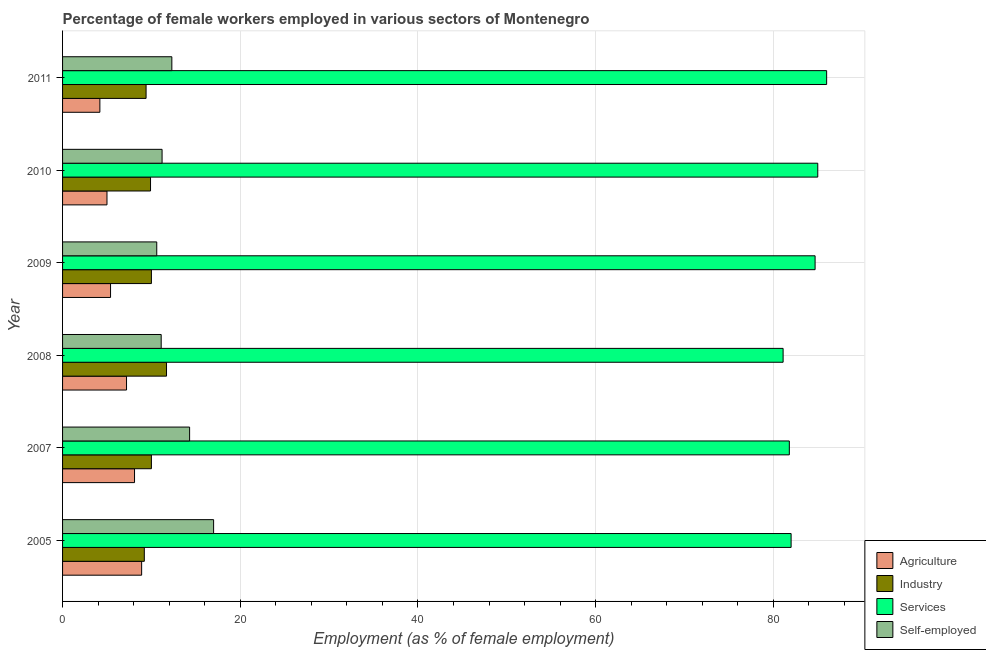How many groups of bars are there?
Make the answer very short. 6. Are the number of bars per tick equal to the number of legend labels?
Your answer should be compact. Yes. Are the number of bars on each tick of the Y-axis equal?
Provide a succinct answer. Yes. What is the label of the 6th group of bars from the top?
Ensure brevity in your answer.  2005. What is the percentage of female workers in agriculture in 2011?
Your answer should be compact. 4.2. Across all years, what is the maximum percentage of female workers in agriculture?
Provide a succinct answer. 8.9. Across all years, what is the minimum percentage of female workers in agriculture?
Your answer should be very brief. 4.2. In which year was the percentage of female workers in industry minimum?
Provide a succinct answer. 2005. What is the total percentage of female workers in industry in the graph?
Offer a terse response. 60.2. What is the difference between the percentage of female workers in services in 2009 and that in 2011?
Offer a very short reply. -1.3. What is the difference between the percentage of female workers in industry in 2005 and the percentage of female workers in agriculture in 2008?
Provide a succinct answer. 2. What is the average percentage of female workers in services per year?
Provide a short and direct response. 83.43. In the year 2007, what is the difference between the percentage of self employed female workers and percentage of female workers in agriculture?
Ensure brevity in your answer.  6.2. What is the ratio of the percentage of self employed female workers in 2007 to that in 2008?
Give a very brief answer. 1.29. Is the percentage of female workers in industry in 2009 less than that in 2010?
Offer a terse response. No. Is the difference between the percentage of female workers in agriculture in 2007 and 2008 greater than the difference between the percentage of self employed female workers in 2007 and 2008?
Keep it short and to the point. No. What is the difference between the highest and the second highest percentage of female workers in agriculture?
Offer a very short reply. 0.8. In how many years, is the percentage of female workers in industry greater than the average percentage of female workers in industry taken over all years?
Your answer should be very brief. 1. Is the sum of the percentage of female workers in industry in 2007 and 2011 greater than the maximum percentage of female workers in services across all years?
Give a very brief answer. No. Is it the case that in every year, the sum of the percentage of female workers in services and percentage of female workers in industry is greater than the sum of percentage of self employed female workers and percentage of female workers in agriculture?
Your answer should be very brief. Yes. What does the 1st bar from the top in 2007 represents?
Provide a succinct answer. Self-employed. What does the 2nd bar from the bottom in 2005 represents?
Give a very brief answer. Industry. How many bars are there?
Offer a very short reply. 24. Are all the bars in the graph horizontal?
Give a very brief answer. Yes. How many years are there in the graph?
Offer a very short reply. 6. What is the title of the graph?
Provide a short and direct response. Percentage of female workers employed in various sectors of Montenegro. Does "Manufacturing" appear as one of the legend labels in the graph?
Your response must be concise. No. What is the label or title of the X-axis?
Your response must be concise. Employment (as % of female employment). What is the Employment (as % of female employment) in Agriculture in 2005?
Keep it short and to the point. 8.9. What is the Employment (as % of female employment) of Industry in 2005?
Offer a very short reply. 9.2. What is the Employment (as % of female employment) in Self-employed in 2005?
Ensure brevity in your answer.  17. What is the Employment (as % of female employment) in Agriculture in 2007?
Your answer should be compact. 8.1. What is the Employment (as % of female employment) of Industry in 2007?
Ensure brevity in your answer.  10. What is the Employment (as % of female employment) of Services in 2007?
Give a very brief answer. 81.8. What is the Employment (as % of female employment) of Self-employed in 2007?
Ensure brevity in your answer.  14.3. What is the Employment (as % of female employment) in Agriculture in 2008?
Your answer should be compact. 7.2. What is the Employment (as % of female employment) in Industry in 2008?
Make the answer very short. 11.7. What is the Employment (as % of female employment) of Services in 2008?
Provide a succinct answer. 81.1. What is the Employment (as % of female employment) in Self-employed in 2008?
Your answer should be compact. 11.1. What is the Employment (as % of female employment) in Agriculture in 2009?
Provide a short and direct response. 5.4. What is the Employment (as % of female employment) of Services in 2009?
Your response must be concise. 84.7. What is the Employment (as % of female employment) in Self-employed in 2009?
Provide a succinct answer. 10.6. What is the Employment (as % of female employment) of Industry in 2010?
Ensure brevity in your answer.  9.9. What is the Employment (as % of female employment) in Self-employed in 2010?
Ensure brevity in your answer.  11.2. What is the Employment (as % of female employment) in Agriculture in 2011?
Provide a succinct answer. 4.2. What is the Employment (as % of female employment) of Industry in 2011?
Your response must be concise. 9.4. What is the Employment (as % of female employment) of Services in 2011?
Offer a terse response. 86. What is the Employment (as % of female employment) of Self-employed in 2011?
Offer a terse response. 12.3. Across all years, what is the maximum Employment (as % of female employment) of Agriculture?
Give a very brief answer. 8.9. Across all years, what is the maximum Employment (as % of female employment) in Industry?
Keep it short and to the point. 11.7. Across all years, what is the maximum Employment (as % of female employment) in Self-employed?
Keep it short and to the point. 17. Across all years, what is the minimum Employment (as % of female employment) in Agriculture?
Your answer should be compact. 4.2. Across all years, what is the minimum Employment (as % of female employment) in Industry?
Make the answer very short. 9.2. Across all years, what is the minimum Employment (as % of female employment) of Services?
Offer a very short reply. 81.1. Across all years, what is the minimum Employment (as % of female employment) in Self-employed?
Ensure brevity in your answer.  10.6. What is the total Employment (as % of female employment) in Agriculture in the graph?
Provide a succinct answer. 38.8. What is the total Employment (as % of female employment) of Industry in the graph?
Offer a terse response. 60.2. What is the total Employment (as % of female employment) of Services in the graph?
Your answer should be compact. 500.6. What is the total Employment (as % of female employment) in Self-employed in the graph?
Your answer should be compact. 76.5. What is the difference between the Employment (as % of female employment) of Agriculture in 2005 and that in 2007?
Provide a short and direct response. 0.8. What is the difference between the Employment (as % of female employment) in Industry in 2005 and that in 2007?
Give a very brief answer. -0.8. What is the difference between the Employment (as % of female employment) of Services in 2005 and that in 2007?
Your answer should be compact. 0.2. What is the difference between the Employment (as % of female employment) of Industry in 2005 and that in 2008?
Offer a terse response. -2.5. What is the difference between the Employment (as % of female employment) of Self-employed in 2005 and that in 2008?
Give a very brief answer. 5.9. What is the difference between the Employment (as % of female employment) in Industry in 2005 and that in 2009?
Keep it short and to the point. -0.8. What is the difference between the Employment (as % of female employment) in Services in 2005 and that in 2009?
Keep it short and to the point. -2.7. What is the difference between the Employment (as % of female employment) of Industry in 2005 and that in 2011?
Your answer should be very brief. -0.2. What is the difference between the Employment (as % of female employment) in Services in 2007 and that in 2008?
Give a very brief answer. 0.7. What is the difference between the Employment (as % of female employment) of Self-employed in 2007 and that in 2008?
Provide a succinct answer. 3.2. What is the difference between the Employment (as % of female employment) in Agriculture in 2007 and that in 2010?
Offer a very short reply. 3.1. What is the difference between the Employment (as % of female employment) in Agriculture in 2007 and that in 2011?
Offer a terse response. 3.9. What is the difference between the Employment (as % of female employment) of Industry in 2007 and that in 2011?
Keep it short and to the point. 0.6. What is the difference between the Employment (as % of female employment) in Services in 2007 and that in 2011?
Your answer should be very brief. -4.2. What is the difference between the Employment (as % of female employment) of Agriculture in 2008 and that in 2009?
Make the answer very short. 1.8. What is the difference between the Employment (as % of female employment) of Industry in 2008 and that in 2009?
Your response must be concise. 1.7. What is the difference between the Employment (as % of female employment) of Services in 2008 and that in 2009?
Keep it short and to the point. -3.6. What is the difference between the Employment (as % of female employment) in Agriculture in 2008 and that in 2010?
Your answer should be compact. 2.2. What is the difference between the Employment (as % of female employment) in Industry in 2008 and that in 2010?
Ensure brevity in your answer.  1.8. What is the difference between the Employment (as % of female employment) in Services in 2008 and that in 2010?
Your response must be concise. -3.9. What is the difference between the Employment (as % of female employment) of Industry in 2008 and that in 2011?
Your answer should be very brief. 2.3. What is the difference between the Employment (as % of female employment) of Self-employed in 2008 and that in 2011?
Offer a terse response. -1.2. What is the difference between the Employment (as % of female employment) of Agriculture in 2009 and that in 2010?
Your answer should be very brief. 0.4. What is the difference between the Employment (as % of female employment) in Self-employed in 2009 and that in 2010?
Offer a very short reply. -0.6. What is the difference between the Employment (as % of female employment) in Industry in 2009 and that in 2011?
Give a very brief answer. 0.6. What is the difference between the Employment (as % of female employment) of Services in 2009 and that in 2011?
Your response must be concise. -1.3. What is the difference between the Employment (as % of female employment) in Agriculture in 2005 and the Employment (as % of female employment) in Industry in 2007?
Ensure brevity in your answer.  -1.1. What is the difference between the Employment (as % of female employment) of Agriculture in 2005 and the Employment (as % of female employment) of Services in 2007?
Offer a very short reply. -72.9. What is the difference between the Employment (as % of female employment) in Industry in 2005 and the Employment (as % of female employment) in Services in 2007?
Ensure brevity in your answer.  -72.6. What is the difference between the Employment (as % of female employment) in Services in 2005 and the Employment (as % of female employment) in Self-employed in 2007?
Offer a very short reply. 67.7. What is the difference between the Employment (as % of female employment) of Agriculture in 2005 and the Employment (as % of female employment) of Industry in 2008?
Your answer should be compact. -2.8. What is the difference between the Employment (as % of female employment) of Agriculture in 2005 and the Employment (as % of female employment) of Services in 2008?
Keep it short and to the point. -72.2. What is the difference between the Employment (as % of female employment) in Agriculture in 2005 and the Employment (as % of female employment) in Self-employed in 2008?
Provide a short and direct response. -2.2. What is the difference between the Employment (as % of female employment) in Industry in 2005 and the Employment (as % of female employment) in Services in 2008?
Keep it short and to the point. -71.9. What is the difference between the Employment (as % of female employment) in Industry in 2005 and the Employment (as % of female employment) in Self-employed in 2008?
Your answer should be compact. -1.9. What is the difference between the Employment (as % of female employment) of Services in 2005 and the Employment (as % of female employment) of Self-employed in 2008?
Offer a terse response. 70.9. What is the difference between the Employment (as % of female employment) of Agriculture in 2005 and the Employment (as % of female employment) of Services in 2009?
Offer a very short reply. -75.8. What is the difference between the Employment (as % of female employment) of Industry in 2005 and the Employment (as % of female employment) of Services in 2009?
Your answer should be very brief. -75.5. What is the difference between the Employment (as % of female employment) in Industry in 2005 and the Employment (as % of female employment) in Self-employed in 2009?
Provide a short and direct response. -1.4. What is the difference between the Employment (as % of female employment) of Services in 2005 and the Employment (as % of female employment) of Self-employed in 2009?
Your answer should be very brief. 71.4. What is the difference between the Employment (as % of female employment) in Agriculture in 2005 and the Employment (as % of female employment) in Industry in 2010?
Offer a very short reply. -1. What is the difference between the Employment (as % of female employment) in Agriculture in 2005 and the Employment (as % of female employment) in Services in 2010?
Your response must be concise. -76.1. What is the difference between the Employment (as % of female employment) in Agriculture in 2005 and the Employment (as % of female employment) in Self-employed in 2010?
Your response must be concise. -2.3. What is the difference between the Employment (as % of female employment) in Industry in 2005 and the Employment (as % of female employment) in Services in 2010?
Ensure brevity in your answer.  -75.8. What is the difference between the Employment (as % of female employment) in Services in 2005 and the Employment (as % of female employment) in Self-employed in 2010?
Make the answer very short. 70.8. What is the difference between the Employment (as % of female employment) of Agriculture in 2005 and the Employment (as % of female employment) of Services in 2011?
Provide a succinct answer. -77.1. What is the difference between the Employment (as % of female employment) in Agriculture in 2005 and the Employment (as % of female employment) in Self-employed in 2011?
Your answer should be very brief. -3.4. What is the difference between the Employment (as % of female employment) of Industry in 2005 and the Employment (as % of female employment) of Services in 2011?
Provide a succinct answer. -76.8. What is the difference between the Employment (as % of female employment) in Services in 2005 and the Employment (as % of female employment) in Self-employed in 2011?
Your response must be concise. 69.7. What is the difference between the Employment (as % of female employment) in Agriculture in 2007 and the Employment (as % of female employment) in Services in 2008?
Your answer should be compact. -73. What is the difference between the Employment (as % of female employment) of Industry in 2007 and the Employment (as % of female employment) of Services in 2008?
Provide a short and direct response. -71.1. What is the difference between the Employment (as % of female employment) of Industry in 2007 and the Employment (as % of female employment) of Self-employed in 2008?
Offer a terse response. -1.1. What is the difference between the Employment (as % of female employment) of Services in 2007 and the Employment (as % of female employment) of Self-employed in 2008?
Your answer should be compact. 70.7. What is the difference between the Employment (as % of female employment) of Agriculture in 2007 and the Employment (as % of female employment) of Industry in 2009?
Your response must be concise. -1.9. What is the difference between the Employment (as % of female employment) in Agriculture in 2007 and the Employment (as % of female employment) in Services in 2009?
Make the answer very short. -76.6. What is the difference between the Employment (as % of female employment) in Industry in 2007 and the Employment (as % of female employment) in Services in 2009?
Keep it short and to the point. -74.7. What is the difference between the Employment (as % of female employment) of Industry in 2007 and the Employment (as % of female employment) of Self-employed in 2009?
Your answer should be compact. -0.6. What is the difference between the Employment (as % of female employment) of Services in 2007 and the Employment (as % of female employment) of Self-employed in 2009?
Offer a very short reply. 71.2. What is the difference between the Employment (as % of female employment) in Agriculture in 2007 and the Employment (as % of female employment) in Services in 2010?
Make the answer very short. -76.9. What is the difference between the Employment (as % of female employment) of Agriculture in 2007 and the Employment (as % of female employment) of Self-employed in 2010?
Offer a very short reply. -3.1. What is the difference between the Employment (as % of female employment) of Industry in 2007 and the Employment (as % of female employment) of Services in 2010?
Ensure brevity in your answer.  -75. What is the difference between the Employment (as % of female employment) in Industry in 2007 and the Employment (as % of female employment) in Self-employed in 2010?
Your response must be concise. -1.2. What is the difference between the Employment (as % of female employment) in Services in 2007 and the Employment (as % of female employment) in Self-employed in 2010?
Make the answer very short. 70.6. What is the difference between the Employment (as % of female employment) in Agriculture in 2007 and the Employment (as % of female employment) in Services in 2011?
Offer a terse response. -77.9. What is the difference between the Employment (as % of female employment) of Agriculture in 2007 and the Employment (as % of female employment) of Self-employed in 2011?
Make the answer very short. -4.2. What is the difference between the Employment (as % of female employment) of Industry in 2007 and the Employment (as % of female employment) of Services in 2011?
Keep it short and to the point. -76. What is the difference between the Employment (as % of female employment) in Industry in 2007 and the Employment (as % of female employment) in Self-employed in 2011?
Keep it short and to the point. -2.3. What is the difference between the Employment (as % of female employment) of Services in 2007 and the Employment (as % of female employment) of Self-employed in 2011?
Provide a succinct answer. 69.5. What is the difference between the Employment (as % of female employment) in Agriculture in 2008 and the Employment (as % of female employment) in Services in 2009?
Offer a terse response. -77.5. What is the difference between the Employment (as % of female employment) in Agriculture in 2008 and the Employment (as % of female employment) in Self-employed in 2009?
Ensure brevity in your answer.  -3.4. What is the difference between the Employment (as % of female employment) of Industry in 2008 and the Employment (as % of female employment) of Services in 2009?
Your response must be concise. -73. What is the difference between the Employment (as % of female employment) in Industry in 2008 and the Employment (as % of female employment) in Self-employed in 2009?
Make the answer very short. 1.1. What is the difference between the Employment (as % of female employment) in Services in 2008 and the Employment (as % of female employment) in Self-employed in 2009?
Your answer should be compact. 70.5. What is the difference between the Employment (as % of female employment) in Agriculture in 2008 and the Employment (as % of female employment) in Services in 2010?
Your answer should be very brief. -77.8. What is the difference between the Employment (as % of female employment) of Agriculture in 2008 and the Employment (as % of female employment) of Self-employed in 2010?
Offer a terse response. -4. What is the difference between the Employment (as % of female employment) in Industry in 2008 and the Employment (as % of female employment) in Services in 2010?
Keep it short and to the point. -73.3. What is the difference between the Employment (as % of female employment) in Services in 2008 and the Employment (as % of female employment) in Self-employed in 2010?
Your answer should be compact. 69.9. What is the difference between the Employment (as % of female employment) in Agriculture in 2008 and the Employment (as % of female employment) in Services in 2011?
Offer a terse response. -78.8. What is the difference between the Employment (as % of female employment) of Industry in 2008 and the Employment (as % of female employment) of Services in 2011?
Offer a very short reply. -74.3. What is the difference between the Employment (as % of female employment) of Services in 2008 and the Employment (as % of female employment) of Self-employed in 2011?
Keep it short and to the point. 68.8. What is the difference between the Employment (as % of female employment) of Agriculture in 2009 and the Employment (as % of female employment) of Industry in 2010?
Offer a terse response. -4.5. What is the difference between the Employment (as % of female employment) in Agriculture in 2009 and the Employment (as % of female employment) in Services in 2010?
Your answer should be very brief. -79.6. What is the difference between the Employment (as % of female employment) in Industry in 2009 and the Employment (as % of female employment) in Services in 2010?
Provide a succinct answer. -75. What is the difference between the Employment (as % of female employment) in Services in 2009 and the Employment (as % of female employment) in Self-employed in 2010?
Your answer should be very brief. 73.5. What is the difference between the Employment (as % of female employment) in Agriculture in 2009 and the Employment (as % of female employment) in Industry in 2011?
Provide a succinct answer. -4. What is the difference between the Employment (as % of female employment) of Agriculture in 2009 and the Employment (as % of female employment) of Services in 2011?
Offer a very short reply. -80.6. What is the difference between the Employment (as % of female employment) in Agriculture in 2009 and the Employment (as % of female employment) in Self-employed in 2011?
Keep it short and to the point. -6.9. What is the difference between the Employment (as % of female employment) in Industry in 2009 and the Employment (as % of female employment) in Services in 2011?
Your answer should be compact. -76. What is the difference between the Employment (as % of female employment) of Industry in 2009 and the Employment (as % of female employment) of Self-employed in 2011?
Provide a short and direct response. -2.3. What is the difference between the Employment (as % of female employment) in Services in 2009 and the Employment (as % of female employment) in Self-employed in 2011?
Ensure brevity in your answer.  72.4. What is the difference between the Employment (as % of female employment) of Agriculture in 2010 and the Employment (as % of female employment) of Services in 2011?
Give a very brief answer. -81. What is the difference between the Employment (as % of female employment) in Agriculture in 2010 and the Employment (as % of female employment) in Self-employed in 2011?
Keep it short and to the point. -7.3. What is the difference between the Employment (as % of female employment) in Industry in 2010 and the Employment (as % of female employment) in Services in 2011?
Your answer should be compact. -76.1. What is the difference between the Employment (as % of female employment) of Industry in 2010 and the Employment (as % of female employment) of Self-employed in 2011?
Your answer should be very brief. -2.4. What is the difference between the Employment (as % of female employment) in Services in 2010 and the Employment (as % of female employment) in Self-employed in 2011?
Your answer should be compact. 72.7. What is the average Employment (as % of female employment) of Agriculture per year?
Your response must be concise. 6.47. What is the average Employment (as % of female employment) of Industry per year?
Your response must be concise. 10.03. What is the average Employment (as % of female employment) in Services per year?
Keep it short and to the point. 83.43. What is the average Employment (as % of female employment) in Self-employed per year?
Your answer should be very brief. 12.75. In the year 2005, what is the difference between the Employment (as % of female employment) of Agriculture and Employment (as % of female employment) of Industry?
Offer a very short reply. -0.3. In the year 2005, what is the difference between the Employment (as % of female employment) in Agriculture and Employment (as % of female employment) in Services?
Keep it short and to the point. -73.1. In the year 2005, what is the difference between the Employment (as % of female employment) in Industry and Employment (as % of female employment) in Services?
Offer a very short reply. -72.8. In the year 2005, what is the difference between the Employment (as % of female employment) of Industry and Employment (as % of female employment) of Self-employed?
Your answer should be very brief. -7.8. In the year 2007, what is the difference between the Employment (as % of female employment) of Agriculture and Employment (as % of female employment) of Services?
Provide a short and direct response. -73.7. In the year 2007, what is the difference between the Employment (as % of female employment) of Agriculture and Employment (as % of female employment) of Self-employed?
Make the answer very short. -6.2. In the year 2007, what is the difference between the Employment (as % of female employment) in Industry and Employment (as % of female employment) in Services?
Make the answer very short. -71.8. In the year 2007, what is the difference between the Employment (as % of female employment) in Industry and Employment (as % of female employment) in Self-employed?
Ensure brevity in your answer.  -4.3. In the year 2007, what is the difference between the Employment (as % of female employment) in Services and Employment (as % of female employment) in Self-employed?
Your answer should be compact. 67.5. In the year 2008, what is the difference between the Employment (as % of female employment) of Agriculture and Employment (as % of female employment) of Industry?
Provide a short and direct response. -4.5. In the year 2008, what is the difference between the Employment (as % of female employment) in Agriculture and Employment (as % of female employment) in Services?
Offer a terse response. -73.9. In the year 2008, what is the difference between the Employment (as % of female employment) of Industry and Employment (as % of female employment) of Services?
Give a very brief answer. -69.4. In the year 2009, what is the difference between the Employment (as % of female employment) of Agriculture and Employment (as % of female employment) of Services?
Make the answer very short. -79.3. In the year 2009, what is the difference between the Employment (as % of female employment) of Industry and Employment (as % of female employment) of Services?
Your answer should be very brief. -74.7. In the year 2009, what is the difference between the Employment (as % of female employment) of Industry and Employment (as % of female employment) of Self-employed?
Your answer should be very brief. -0.6. In the year 2009, what is the difference between the Employment (as % of female employment) of Services and Employment (as % of female employment) of Self-employed?
Make the answer very short. 74.1. In the year 2010, what is the difference between the Employment (as % of female employment) of Agriculture and Employment (as % of female employment) of Services?
Offer a terse response. -80. In the year 2010, what is the difference between the Employment (as % of female employment) of Agriculture and Employment (as % of female employment) of Self-employed?
Ensure brevity in your answer.  -6.2. In the year 2010, what is the difference between the Employment (as % of female employment) of Industry and Employment (as % of female employment) of Services?
Your response must be concise. -75.1. In the year 2010, what is the difference between the Employment (as % of female employment) in Industry and Employment (as % of female employment) in Self-employed?
Your response must be concise. -1.3. In the year 2010, what is the difference between the Employment (as % of female employment) of Services and Employment (as % of female employment) of Self-employed?
Provide a short and direct response. 73.8. In the year 2011, what is the difference between the Employment (as % of female employment) in Agriculture and Employment (as % of female employment) in Services?
Give a very brief answer. -81.8. In the year 2011, what is the difference between the Employment (as % of female employment) in Industry and Employment (as % of female employment) in Services?
Offer a very short reply. -76.6. In the year 2011, what is the difference between the Employment (as % of female employment) of Industry and Employment (as % of female employment) of Self-employed?
Offer a terse response. -2.9. In the year 2011, what is the difference between the Employment (as % of female employment) of Services and Employment (as % of female employment) of Self-employed?
Give a very brief answer. 73.7. What is the ratio of the Employment (as % of female employment) of Agriculture in 2005 to that in 2007?
Offer a terse response. 1.1. What is the ratio of the Employment (as % of female employment) of Industry in 2005 to that in 2007?
Offer a terse response. 0.92. What is the ratio of the Employment (as % of female employment) in Self-employed in 2005 to that in 2007?
Make the answer very short. 1.19. What is the ratio of the Employment (as % of female employment) in Agriculture in 2005 to that in 2008?
Give a very brief answer. 1.24. What is the ratio of the Employment (as % of female employment) in Industry in 2005 to that in 2008?
Make the answer very short. 0.79. What is the ratio of the Employment (as % of female employment) of Services in 2005 to that in 2008?
Keep it short and to the point. 1.01. What is the ratio of the Employment (as % of female employment) of Self-employed in 2005 to that in 2008?
Your answer should be compact. 1.53. What is the ratio of the Employment (as % of female employment) in Agriculture in 2005 to that in 2009?
Make the answer very short. 1.65. What is the ratio of the Employment (as % of female employment) of Services in 2005 to that in 2009?
Offer a very short reply. 0.97. What is the ratio of the Employment (as % of female employment) in Self-employed in 2005 to that in 2009?
Offer a terse response. 1.6. What is the ratio of the Employment (as % of female employment) of Agriculture in 2005 to that in 2010?
Keep it short and to the point. 1.78. What is the ratio of the Employment (as % of female employment) of Industry in 2005 to that in 2010?
Your answer should be compact. 0.93. What is the ratio of the Employment (as % of female employment) of Services in 2005 to that in 2010?
Keep it short and to the point. 0.96. What is the ratio of the Employment (as % of female employment) in Self-employed in 2005 to that in 2010?
Keep it short and to the point. 1.52. What is the ratio of the Employment (as % of female employment) of Agriculture in 2005 to that in 2011?
Your answer should be very brief. 2.12. What is the ratio of the Employment (as % of female employment) in Industry in 2005 to that in 2011?
Offer a very short reply. 0.98. What is the ratio of the Employment (as % of female employment) in Services in 2005 to that in 2011?
Your response must be concise. 0.95. What is the ratio of the Employment (as % of female employment) in Self-employed in 2005 to that in 2011?
Keep it short and to the point. 1.38. What is the ratio of the Employment (as % of female employment) in Agriculture in 2007 to that in 2008?
Make the answer very short. 1.12. What is the ratio of the Employment (as % of female employment) of Industry in 2007 to that in 2008?
Ensure brevity in your answer.  0.85. What is the ratio of the Employment (as % of female employment) in Services in 2007 to that in 2008?
Ensure brevity in your answer.  1.01. What is the ratio of the Employment (as % of female employment) of Self-employed in 2007 to that in 2008?
Your answer should be compact. 1.29. What is the ratio of the Employment (as % of female employment) in Agriculture in 2007 to that in 2009?
Your response must be concise. 1.5. What is the ratio of the Employment (as % of female employment) in Industry in 2007 to that in 2009?
Your answer should be very brief. 1. What is the ratio of the Employment (as % of female employment) of Services in 2007 to that in 2009?
Offer a terse response. 0.97. What is the ratio of the Employment (as % of female employment) in Self-employed in 2007 to that in 2009?
Give a very brief answer. 1.35. What is the ratio of the Employment (as % of female employment) in Agriculture in 2007 to that in 2010?
Provide a short and direct response. 1.62. What is the ratio of the Employment (as % of female employment) in Industry in 2007 to that in 2010?
Keep it short and to the point. 1.01. What is the ratio of the Employment (as % of female employment) of Services in 2007 to that in 2010?
Provide a short and direct response. 0.96. What is the ratio of the Employment (as % of female employment) of Self-employed in 2007 to that in 2010?
Ensure brevity in your answer.  1.28. What is the ratio of the Employment (as % of female employment) in Agriculture in 2007 to that in 2011?
Your answer should be compact. 1.93. What is the ratio of the Employment (as % of female employment) in Industry in 2007 to that in 2011?
Offer a very short reply. 1.06. What is the ratio of the Employment (as % of female employment) of Services in 2007 to that in 2011?
Give a very brief answer. 0.95. What is the ratio of the Employment (as % of female employment) of Self-employed in 2007 to that in 2011?
Your response must be concise. 1.16. What is the ratio of the Employment (as % of female employment) in Agriculture in 2008 to that in 2009?
Offer a terse response. 1.33. What is the ratio of the Employment (as % of female employment) of Industry in 2008 to that in 2009?
Ensure brevity in your answer.  1.17. What is the ratio of the Employment (as % of female employment) of Services in 2008 to that in 2009?
Give a very brief answer. 0.96. What is the ratio of the Employment (as % of female employment) of Self-employed in 2008 to that in 2009?
Your answer should be very brief. 1.05. What is the ratio of the Employment (as % of female employment) in Agriculture in 2008 to that in 2010?
Provide a short and direct response. 1.44. What is the ratio of the Employment (as % of female employment) in Industry in 2008 to that in 2010?
Your answer should be compact. 1.18. What is the ratio of the Employment (as % of female employment) in Services in 2008 to that in 2010?
Offer a very short reply. 0.95. What is the ratio of the Employment (as % of female employment) of Agriculture in 2008 to that in 2011?
Your answer should be very brief. 1.71. What is the ratio of the Employment (as % of female employment) in Industry in 2008 to that in 2011?
Ensure brevity in your answer.  1.24. What is the ratio of the Employment (as % of female employment) of Services in 2008 to that in 2011?
Provide a succinct answer. 0.94. What is the ratio of the Employment (as % of female employment) in Self-employed in 2008 to that in 2011?
Offer a terse response. 0.9. What is the ratio of the Employment (as % of female employment) in Self-employed in 2009 to that in 2010?
Provide a short and direct response. 0.95. What is the ratio of the Employment (as % of female employment) of Industry in 2009 to that in 2011?
Ensure brevity in your answer.  1.06. What is the ratio of the Employment (as % of female employment) of Services in 2009 to that in 2011?
Ensure brevity in your answer.  0.98. What is the ratio of the Employment (as % of female employment) of Self-employed in 2009 to that in 2011?
Your response must be concise. 0.86. What is the ratio of the Employment (as % of female employment) in Agriculture in 2010 to that in 2011?
Offer a very short reply. 1.19. What is the ratio of the Employment (as % of female employment) of Industry in 2010 to that in 2011?
Your response must be concise. 1.05. What is the ratio of the Employment (as % of female employment) in Services in 2010 to that in 2011?
Keep it short and to the point. 0.99. What is the ratio of the Employment (as % of female employment) of Self-employed in 2010 to that in 2011?
Provide a succinct answer. 0.91. What is the difference between the highest and the second highest Employment (as % of female employment) in Industry?
Keep it short and to the point. 1.7. What is the difference between the highest and the second highest Employment (as % of female employment) of Self-employed?
Your answer should be compact. 2.7. What is the difference between the highest and the lowest Employment (as % of female employment) in Agriculture?
Ensure brevity in your answer.  4.7. What is the difference between the highest and the lowest Employment (as % of female employment) in Self-employed?
Your answer should be compact. 6.4. 